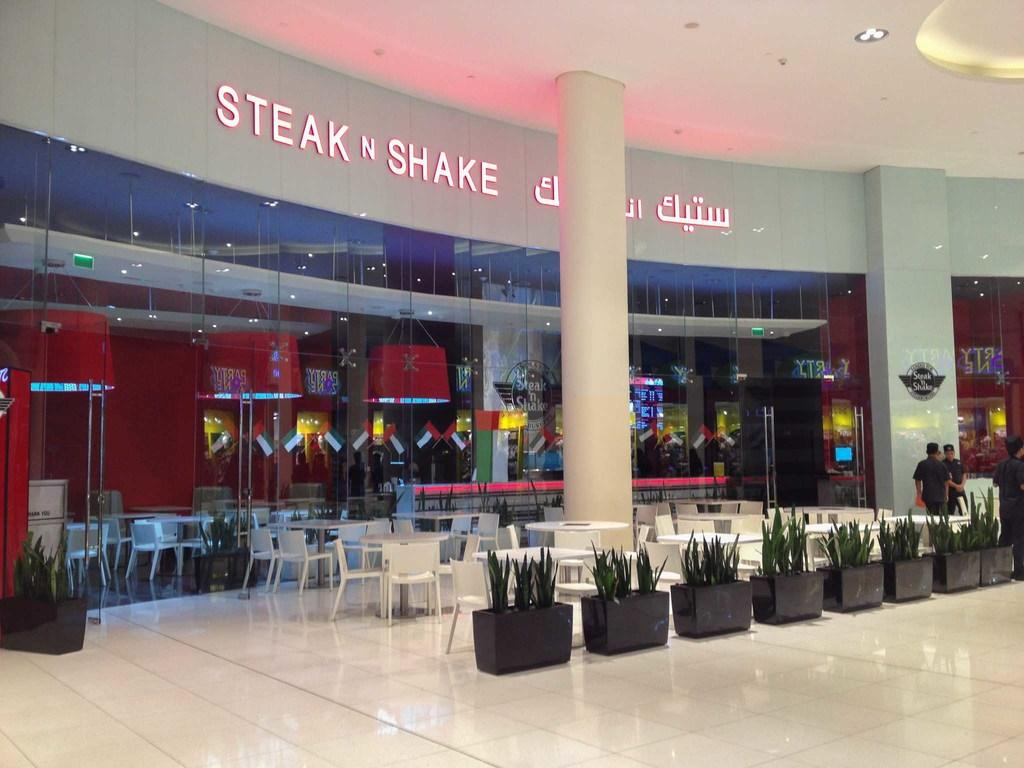<image>
Render a clear and concise summary of the photo. The Steak N Shake restaurant has many white tables and chairs outside in the mall area. 